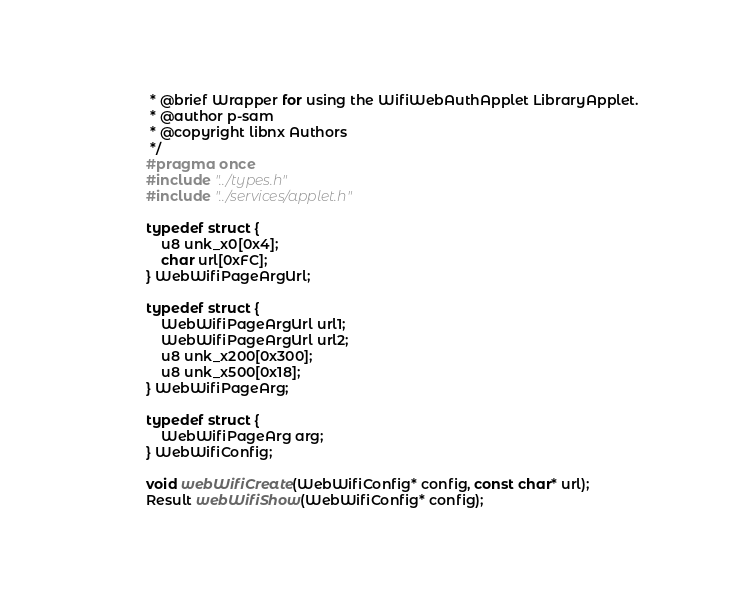Convert code to text. <code><loc_0><loc_0><loc_500><loc_500><_C_> * @brief Wrapper for using the WifiWebAuthApplet LibraryApplet.
 * @author p-sam
 * @copyright libnx Authors
 */
#pragma once
#include "../types.h"
#include "../services/applet.h"

typedef struct {
    u8 unk_x0[0x4];
    char url[0xFC];
} WebWifiPageArgUrl;

typedef struct {
    WebWifiPageArgUrl url1;
    WebWifiPageArgUrl url2;
    u8 unk_x200[0x300];
    u8 unk_x500[0x18];
} WebWifiPageArg;

typedef struct {
    WebWifiPageArg arg;
} WebWifiConfig;

void webWifiCreate(WebWifiConfig* config, const char* url);
Result webWifiShow(WebWifiConfig* config);
</code> 